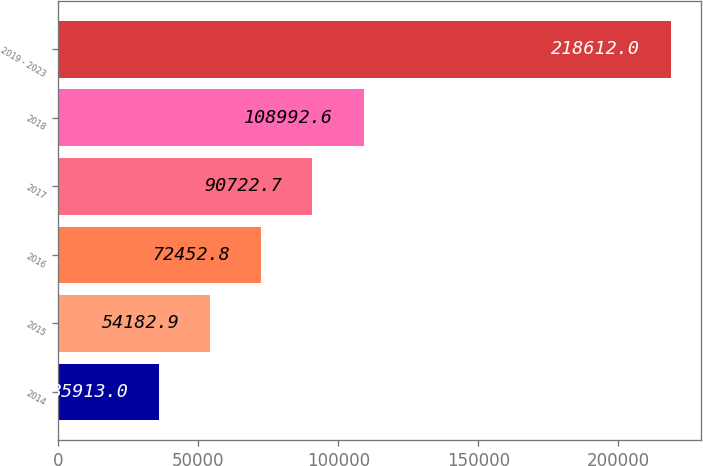Convert chart. <chart><loc_0><loc_0><loc_500><loc_500><bar_chart><fcel>2014<fcel>2015<fcel>2016<fcel>2017<fcel>2018<fcel>2019 - 2023<nl><fcel>35913<fcel>54182.9<fcel>72452.8<fcel>90722.7<fcel>108993<fcel>218612<nl></chart> 